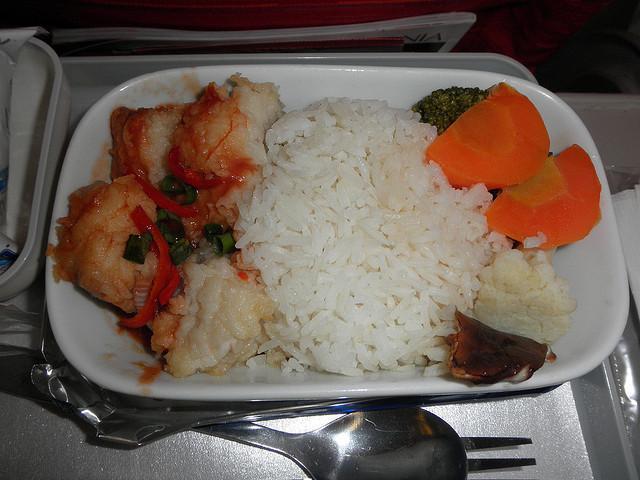On which plant does the vegetable that is reddest here grow?
Choose the right answer from the provided options to respond to the question.
Options: Cauliflower, carrot, pepper, corn. Pepper. 